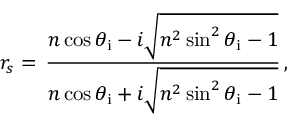Convert formula to latex. <formula><loc_0><loc_0><loc_500><loc_500>r _ { s } = \, { \frac { n \cos \theta _ { i } - i { \sqrt { n ^ { 2 } \sin ^ { 2 } \theta _ { i } - 1 } } } { n \cos \theta _ { i } + i { \sqrt { n ^ { 2 } \sin ^ { 2 } \theta _ { i } - 1 } } } } \, ,</formula> 